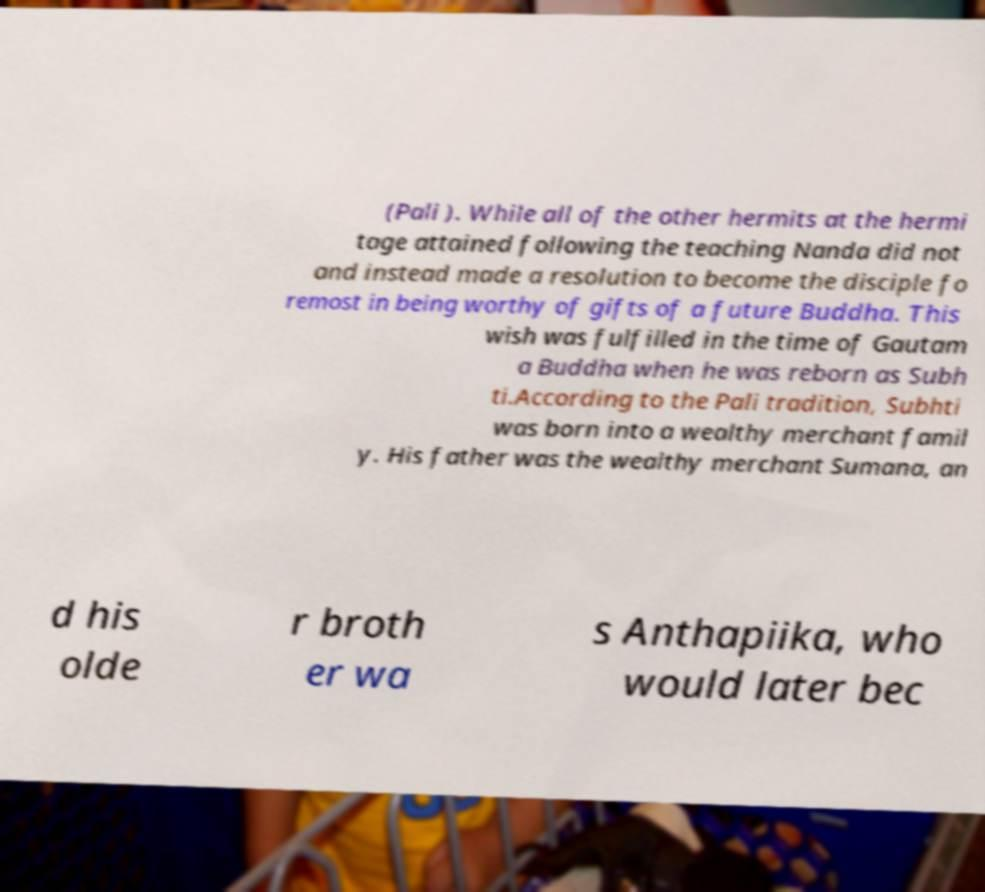Could you extract and type out the text from this image? (Pali ). While all of the other hermits at the hermi tage attained following the teaching Nanda did not and instead made a resolution to become the disciple fo remost in being worthy of gifts of a future Buddha. This wish was fulfilled in the time of Gautam a Buddha when he was reborn as Subh ti.According to the Pali tradition, Subhti was born into a wealthy merchant famil y. His father was the wealthy merchant Sumana, an d his olde r broth er wa s Anthapiika, who would later bec 